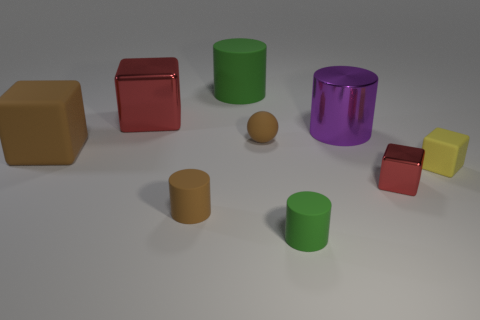Subtract all green cylinders. How many were subtracted if there are1green cylinders left? 1 Subtract all tiny red metallic blocks. How many blocks are left? 3 Add 1 tiny purple cylinders. How many objects exist? 10 Subtract all green cylinders. How many cylinders are left? 2 Subtract all blue cylinders. Subtract all cyan balls. How many cylinders are left? 4 Subtract all red metal things. Subtract all big green matte objects. How many objects are left? 6 Add 4 tiny rubber objects. How many tiny rubber objects are left? 8 Add 7 small cyan matte cylinders. How many small cyan matte cylinders exist? 7 Subtract 0 blue spheres. How many objects are left? 9 Subtract all cylinders. How many objects are left? 5 